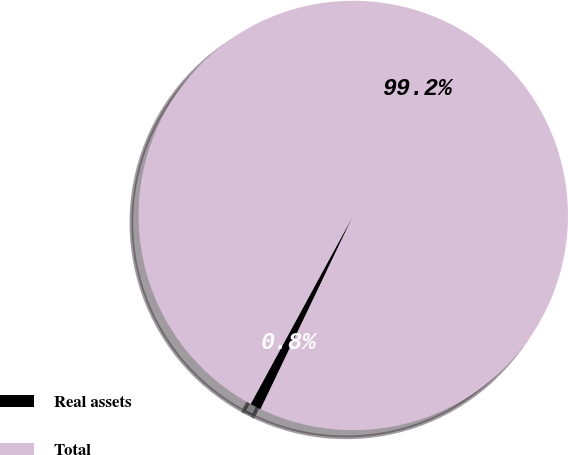Convert chart to OTSL. <chart><loc_0><loc_0><loc_500><loc_500><pie_chart><fcel>Real assets<fcel>Total<nl><fcel>0.83%<fcel>99.17%<nl></chart> 